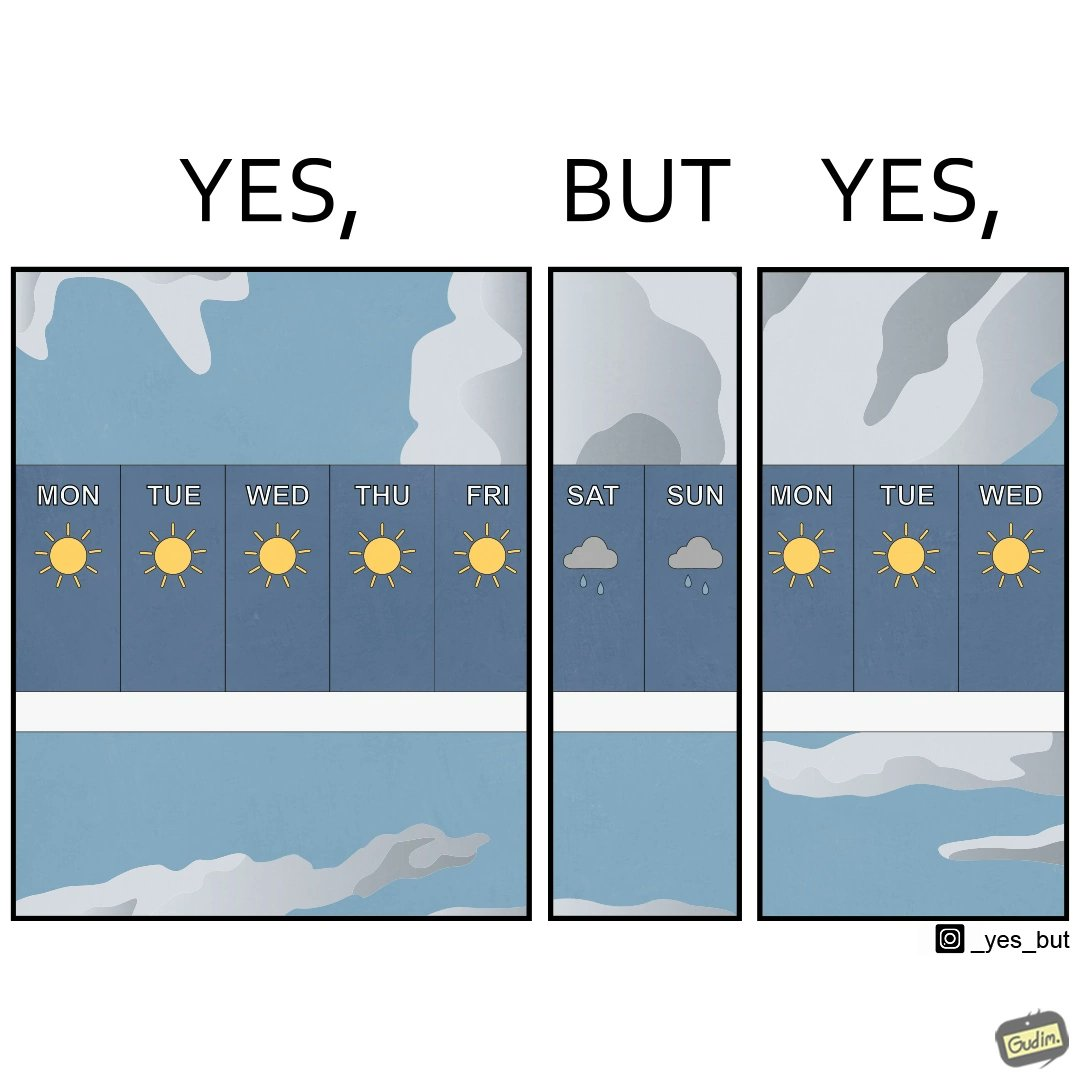What is the satirical meaning behind this image? The image is funny, as the weather is sunny during the weekdays, which are generally the days when people work in a job. People look forward to go outside and enjoy in the weekend, but due to an unexpected rainy weather, people will not be able to go outside. 